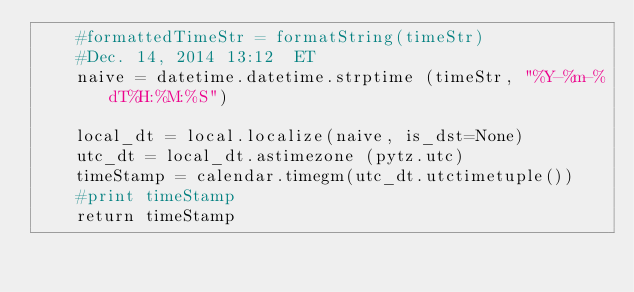<code> <loc_0><loc_0><loc_500><loc_500><_Python_>	#formattedTimeStr = formatString(timeStr)
	#Dec. 14, 2014 13:12  ET
	naive = datetime.datetime.strptime (timeStr, "%Y-%m-%dT%H:%M:%S")

	local_dt = local.localize(naive, is_dst=None)
	utc_dt = local_dt.astimezone (pytz.utc)
	timeStamp = calendar.timegm(utc_dt.utctimetuple())
	#print timeStamp
	return timeStamp</code> 